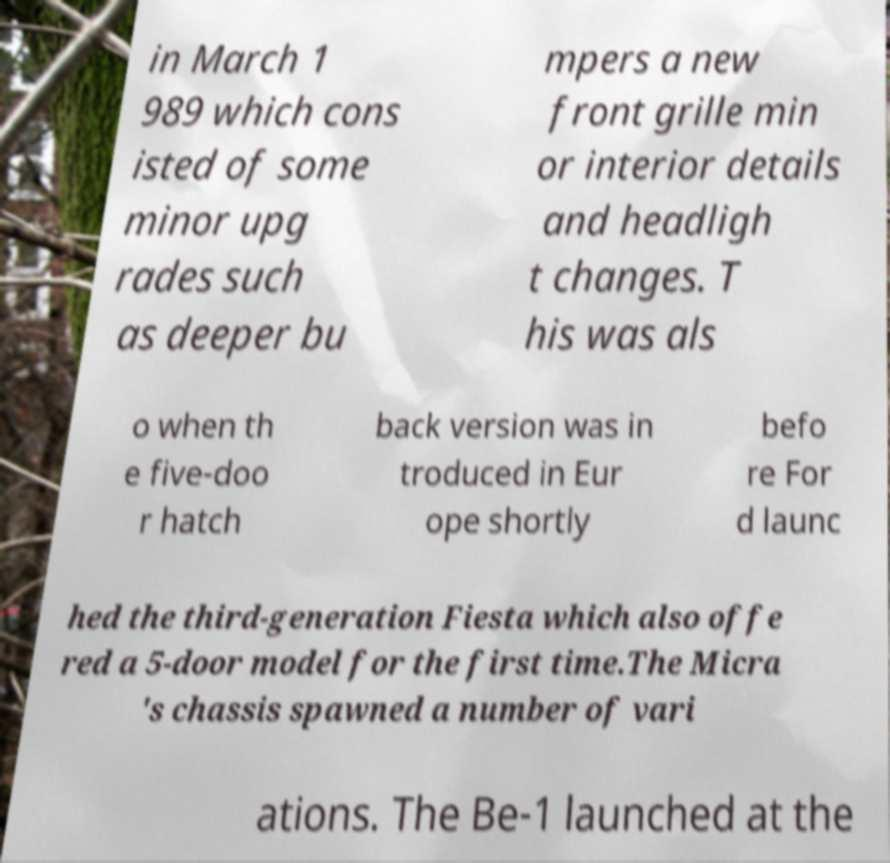What messages or text are displayed in this image? I need them in a readable, typed format. in March 1 989 which cons isted of some minor upg rades such as deeper bu mpers a new front grille min or interior details and headligh t changes. T his was als o when th e five-doo r hatch back version was in troduced in Eur ope shortly befo re For d launc hed the third-generation Fiesta which also offe red a 5-door model for the first time.The Micra 's chassis spawned a number of vari ations. The Be-1 launched at the 